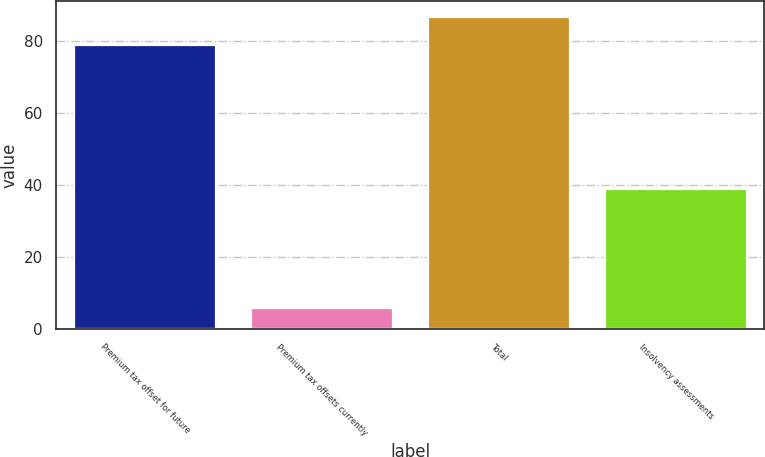Convert chart. <chart><loc_0><loc_0><loc_500><loc_500><bar_chart><fcel>Premium tax offset for future<fcel>Premium tax offsets currently<fcel>Total<fcel>Insolvency assessments<nl><fcel>79<fcel>6<fcel>86.9<fcel>39<nl></chart> 